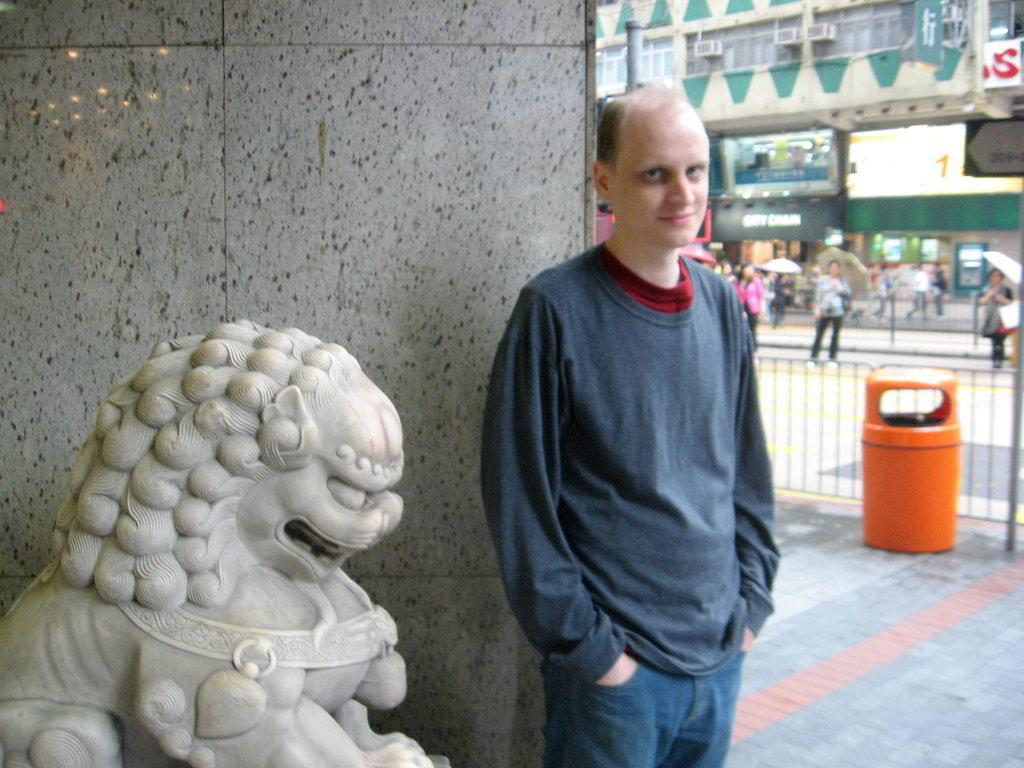What type of structures can be seen in the image? There are buildings in the image. What additional objects are present in the image? There are banners, a group of people, umbrellas, a statue, a dustbin, and a man standing in the front of the image. What is the man in the front of the image wearing? The man is wearing a blue color t-shirt. Who is the owner of the bottle in the image? There is no bottle present in the image. How many groups of people are there in the image? There is only one group of people in the image. 